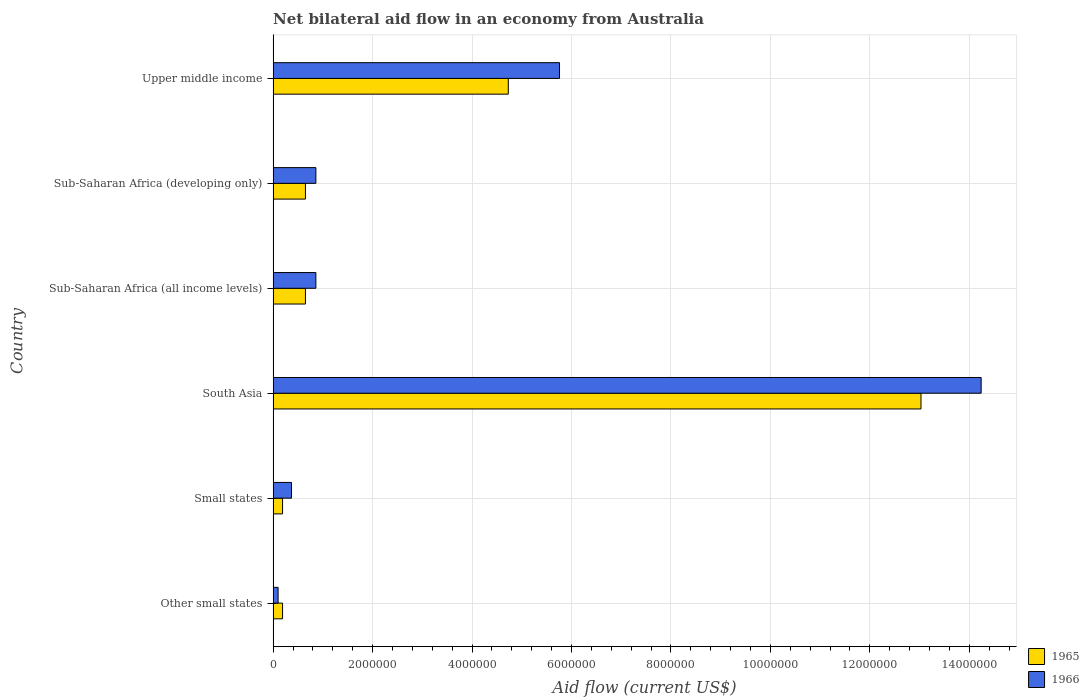How many different coloured bars are there?
Give a very brief answer. 2. Are the number of bars per tick equal to the number of legend labels?
Give a very brief answer. Yes. Are the number of bars on each tick of the Y-axis equal?
Your answer should be compact. Yes. How many bars are there on the 3rd tick from the top?
Make the answer very short. 2. How many bars are there on the 2nd tick from the bottom?
Your answer should be compact. 2. What is the label of the 5th group of bars from the top?
Keep it short and to the point. Small states. What is the net bilateral aid flow in 1965 in Sub-Saharan Africa (developing only)?
Keep it short and to the point. 6.50e+05. Across all countries, what is the maximum net bilateral aid flow in 1965?
Offer a terse response. 1.30e+07. Across all countries, what is the minimum net bilateral aid flow in 1965?
Keep it short and to the point. 1.90e+05. In which country was the net bilateral aid flow in 1965 maximum?
Your answer should be compact. South Asia. In which country was the net bilateral aid flow in 1966 minimum?
Your answer should be compact. Other small states. What is the total net bilateral aid flow in 1965 in the graph?
Offer a very short reply. 1.94e+07. What is the difference between the net bilateral aid flow in 1966 in Other small states and that in Sub-Saharan Africa (all income levels)?
Offer a terse response. -7.60e+05. What is the difference between the net bilateral aid flow in 1966 in Upper middle income and the net bilateral aid flow in 1965 in Other small states?
Your response must be concise. 5.57e+06. What is the average net bilateral aid flow in 1965 per country?
Ensure brevity in your answer.  3.24e+06. What is the difference between the net bilateral aid flow in 1965 and net bilateral aid flow in 1966 in Upper middle income?
Your response must be concise. -1.03e+06. In how many countries, is the net bilateral aid flow in 1966 greater than 6400000 US$?
Your answer should be very brief. 1. What is the ratio of the net bilateral aid flow in 1966 in Other small states to that in Sub-Saharan Africa (developing only)?
Your response must be concise. 0.12. Is the net bilateral aid flow in 1965 in Small states less than that in Sub-Saharan Africa (developing only)?
Ensure brevity in your answer.  Yes. Is the difference between the net bilateral aid flow in 1965 in South Asia and Sub-Saharan Africa (all income levels) greater than the difference between the net bilateral aid flow in 1966 in South Asia and Sub-Saharan Africa (all income levels)?
Give a very brief answer. No. What is the difference between the highest and the second highest net bilateral aid flow in 1965?
Keep it short and to the point. 8.30e+06. What is the difference between the highest and the lowest net bilateral aid flow in 1966?
Give a very brief answer. 1.41e+07. Is the sum of the net bilateral aid flow in 1966 in Sub-Saharan Africa (developing only) and Upper middle income greater than the maximum net bilateral aid flow in 1965 across all countries?
Make the answer very short. No. What does the 1st bar from the top in Other small states represents?
Offer a terse response. 1966. What does the 2nd bar from the bottom in Sub-Saharan Africa (all income levels) represents?
Make the answer very short. 1966. Are all the bars in the graph horizontal?
Offer a terse response. Yes. Are the values on the major ticks of X-axis written in scientific E-notation?
Make the answer very short. No. Does the graph contain any zero values?
Keep it short and to the point. No. Does the graph contain grids?
Offer a very short reply. Yes. Where does the legend appear in the graph?
Keep it short and to the point. Bottom right. How many legend labels are there?
Ensure brevity in your answer.  2. What is the title of the graph?
Your response must be concise. Net bilateral aid flow in an economy from Australia. What is the Aid flow (current US$) of 1965 in Other small states?
Give a very brief answer. 1.90e+05. What is the Aid flow (current US$) of 1965 in South Asia?
Your answer should be very brief. 1.30e+07. What is the Aid flow (current US$) of 1966 in South Asia?
Give a very brief answer. 1.42e+07. What is the Aid flow (current US$) of 1965 in Sub-Saharan Africa (all income levels)?
Offer a very short reply. 6.50e+05. What is the Aid flow (current US$) in 1966 in Sub-Saharan Africa (all income levels)?
Offer a very short reply. 8.60e+05. What is the Aid flow (current US$) in 1965 in Sub-Saharan Africa (developing only)?
Your answer should be compact. 6.50e+05. What is the Aid flow (current US$) of 1966 in Sub-Saharan Africa (developing only)?
Ensure brevity in your answer.  8.60e+05. What is the Aid flow (current US$) in 1965 in Upper middle income?
Your answer should be very brief. 4.73e+06. What is the Aid flow (current US$) of 1966 in Upper middle income?
Your response must be concise. 5.76e+06. Across all countries, what is the maximum Aid flow (current US$) of 1965?
Give a very brief answer. 1.30e+07. Across all countries, what is the maximum Aid flow (current US$) of 1966?
Your response must be concise. 1.42e+07. Across all countries, what is the minimum Aid flow (current US$) in 1965?
Your answer should be very brief. 1.90e+05. What is the total Aid flow (current US$) of 1965 in the graph?
Your answer should be very brief. 1.94e+07. What is the total Aid flow (current US$) of 1966 in the graph?
Provide a short and direct response. 2.22e+07. What is the difference between the Aid flow (current US$) in 1966 in Other small states and that in Small states?
Keep it short and to the point. -2.70e+05. What is the difference between the Aid flow (current US$) in 1965 in Other small states and that in South Asia?
Your answer should be compact. -1.28e+07. What is the difference between the Aid flow (current US$) of 1966 in Other small states and that in South Asia?
Your response must be concise. -1.41e+07. What is the difference between the Aid flow (current US$) in 1965 in Other small states and that in Sub-Saharan Africa (all income levels)?
Your answer should be compact. -4.60e+05. What is the difference between the Aid flow (current US$) of 1966 in Other small states and that in Sub-Saharan Africa (all income levels)?
Make the answer very short. -7.60e+05. What is the difference between the Aid flow (current US$) in 1965 in Other small states and that in Sub-Saharan Africa (developing only)?
Provide a succinct answer. -4.60e+05. What is the difference between the Aid flow (current US$) in 1966 in Other small states and that in Sub-Saharan Africa (developing only)?
Provide a succinct answer. -7.60e+05. What is the difference between the Aid flow (current US$) in 1965 in Other small states and that in Upper middle income?
Ensure brevity in your answer.  -4.54e+06. What is the difference between the Aid flow (current US$) of 1966 in Other small states and that in Upper middle income?
Offer a very short reply. -5.66e+06. What is the difference between the Aid flow (current US$) in 1965 in Small states and that in South Asia?
Provide a short and direct response. -1.28e+07. What is the difference between the Aid flow (current US$) in 1966 in Small states and that in South Asia?
Provide a succinct answer. -1.39e+07. What is the difference between the Aid flow (current US$) in 1965 in Small states and that in Sub-Saharan Africa (all income levels)?
Offer a very short reply. -4.60e+05. What is the difference between the Aid flow (current US$) of 1966 in Small states and that in Sub-Saharan Africa (all income levels)?
Make the answer very short. -4.90e+05. What is the difference between the Aid flow (current US$) in 1965 in Small states and that in Sub-Saharan Africa (developing only)?
Make the answer very short. -4.60e+05. What is the difference between the Aid flow (current US$) in 1966 in Small states and that in Sub-Saharan Africa (developing only)?
Provide a short and direct response. -4.90e+05. What is the difference between the Aid flow (current US$) in 1965 in Small states and that in Upper middle income?
Offer a very short reply. -4.54e+06. What is the difference between the Aid flow (current US$) of 1966 in Small states and that in Upper middle income?
Give a very brief answer. -5.39e+06. What is the difference between the Aid flow (current US$) in 1965 in South Asia and that in Sub-Saharan Africa (all income levels)?
Offer a terse response. 1.24e+07. What is the difference between the Aid flow (current US$) in 1966 in South Asia and that in Sub-Saharan Africa (all income levels)?
Your answer should be compact. 1.34e+07. What is the difference between the Aid flow (current US$) of 1965 in South Asia and that in Sub-Saharan Africa (developing only)?
Make the answer very short. 1.24e+07. What is the difference between the Aid flow (current US$) in 1966 in South Asia and that in Sub-Saharan Africa (developing only)?
Offer a very short reply. 1.34e+07. What is the difference between the Aid flow (current US$) in 1965 in South Asia and that in Upper middle income?
Keep it short and to the point. 8.30e+06. What is the difference between the Aid flow (current US$) in 1966 in South Asia and that in Upper middle income?
Keep it short and to the point. 8.48e+06. What is the difference between the Aid flow (current US$) in 1965 in Sub-Saharan Africa (all income levels) and that in Sub-Saharan Africa (developing only)?
Provide a succinct answer. 0. What is the difference between the Aid flow (current US$) of 1966 in Sub-Saharan Africa (all income levels) and that in Sub-Saharan Africa (developing only)?
Ensure brevity in your answer.  0. What is the difference between the Aid flow (current US$) of 1965 in Sub-Saharan Africa (all income levels) and that in Upper middle income?
Offer a very short reply. -4.08e+06. What is the difference between the Aid flow (current US$) in 1966 in Sub-Saharan Africa (all income levels) and that in Upper middle income?
Offer a very short reply. -4.90e+06. What is the difference between the Aid flow (current US$) in 1965 in Sub-Saharan Africa (developing only) and that in Upper middle income?
Make the answer very short. -4.08e+06. What is the difference between the Aid flow (current US$) in 1966 in Sub-Saharan Africa (developing only) and that in Upper middle income?
Offer a terse response. -4.90e+06. What is the difference between the Aid flow (current US$) in 1965 in Other small states and the Aid flow (current US$) in 1966 in South Asia?
Your answer should be compact. -1.40e+07. What is the difference between the Aid flow (current US$) in 1965 in Other small states and the Aid flow (current US$) in 1966 in Sub-Saharan Africa (all income levels)?
Provide a short and direct response. -6.70e+05. What is the difference between the Aid flow (current US$) in 1965 in Other small states and the Aid flow (current US$) in 1966 in Sub-Saharan Africa (developing only)?
Offer a very short reply. -6.70e+05. What is the difference between the Aid flow (current US$) in 1965 in Other small states and the Aid flow (current US$) in 1966 in Upper middle income?
Your answer should be compact. -5.57e+06. What is the difference between the Aid flow (current US$) of 1965 in Small states and the Aid flow (current US$) of 1966 in South Asia?
Your response must be concise. -1.40e+07. What is the difference between the Aid flow (current US$) in 1965 in Small states and the Aid flow (current US$) in 1966 in Sub-Saharan Africa (all income levels)?
Provide a short and direct response. -6.70e+05. What is the difference between the Aid flow (current US$) in 1965 in Small states and the Aid flow (current US$) in 1966 in Sub-Saharan Africa (developing only)?
Make the answer very short. -6.70e+05. What is the difference between the Aid flow (current US$) in 1965 in Small states and the Aid flow (current US$) in 1966 in Upper middle income?
Ensure brevity in your answer.  -5.57e+06. What is the difference between the Aid flow (current US$) of 1965 in South Asia and the Aid flow (current US$) of 1966 in Sub-Saharan Africa (all income levels)?
Give a very brief answer. 1.22e+07. What is the difference between the Aid flow (current US$) of 1965 in South Asia and the Aid flow (current US$) of 1966 in Sub-Saharan Africa (developing only)?
Offer a terse response. 1.22e+07. What is the difference between the Aid flow (current US$) in 1965 in South Asia and the Aid flow (current US$) in 1966 in Upper middle income?
Give a very brief answer. 7.27e+06. What is the difference between the Aid flow (current US$) in 1965 in Sub-Saharan Africa (all income levels) and the Aid flow (current US$) in 1966 in Upper middle income?
Give a very brief answer. -5.11e+06. What is the difference between the Aid flow (current US$) of 1965 in Sub-Saharan Africa (developing only) and the Aid flow (current US$) of 1966 in Upper middle income?
Make the answer very short. -5.11e+06. What is the average Aid flow (current US$) of 1965 per country?
Provide a succinct answer. 3.24e+06. What is the average Aid flow (current US$) of 1966 per country?
Ensure brevity in your answer.  3.70e+06. What is the difference between the Aid flow (current US$) in 1965 and Aid flow (current US$) in 1966 in South Asia?
Offer a terse response. -1.21e+06. What is the difference between the Aid flow (current US$) of 1965 and Aid flow (current US$) of 1966 in Sub-Saharan Africa (all income levels)?
Offer a terse response. -2.10e+05. What is the difference between the Aid flow (current US$) in 1965 and Aid flow (current US$) in 1966 in Upper middle income?
Your response must be concise. -1.03e+06. What is the ratio of the Aid flow (current US$) in 1965 in Other small states to that in Small states?
Provide a succinct answer. 1. What is the ratio of the Aid flow (current US$) in 1966 in Other small states to that in Small states?
Your answer should be very brief. 0.27. What is the ratio of the Aid flow (current US$) of 1965 in Other small states to that in South Asia?
Offer a very short reply. 0.01. What is the ratio of the Aid flow (current US$) of 1966 in Other small states to that in South Asia?
Your response must be concise. 0.01. What is the ratio of the Aid flow (current US$) of 1965 in Other small states to that in Sub-Saharan Africa (all income levels)?
Offer a terse response. 0.29. What is the ratio of the Aid flow (current US$) in 1966 in Other small states to that in Sub-Saharan Africa (all income levels)?
Your answer should be compact. 0.12. What is the ratio of the Aid flow (current US$) in 1965 in Other small states to that in Sub-Saharan Africa (developing only)?
Your response must be concise. 0.29. What is the ratio of the Aid flow (current US$) of 1966 in Other small states to that in Sub-Saharan Africa (developing only)?
Provide a short and direct response. 0.12. What is the ratio of the Aid flow (current US$) in 1965 in Other small states to that in Upper middle income?
Offer a terse response. 0.04. What is the ratio of the Aid flow (current US$) in 1966 in Other small states to that in Upper middle income?
Ensure brevity in your answer.  0.02. What is the ratio of the Aid flow (current US$) of 1965 in Small states to that in South Asia?
Provide a succinct answer. 0.01. What is the ratio of the Aid flow (current US$) of 1966 in Small states to that in South Asia?
Your answer should be very brief. 0.03. What is the ratio of the Aid flow (current US$) of 1965 in Small states to that in Sub-Saharan Africa (all income levels)?
Provide a short and direct response. 0.29. What is the ratio of the Aid flow (current US$) in 1966 in Small states to that in Sub-Saharan Africa (all income levels)?
Provide a short and direct response. 0.43. What is the ratio of the Aid flow (current US$) in 1965 in Small states to that in Sub-Saharan Africa (developing only)?
Offer a terse response. 0.29. What is the ratio of the Aid flow (current US$) of 1966 in Small states to that in Sub-Saharan Africa (developing only)?
Provide a short and direct response. 0.43. What is the ratio of the Aid flow (current US$) in 1965 in Small states to that in Upper middle income?
Your answer should be compact. 0.04. What is the ratio of the Aid flow (current US$) of 1966 in Small states to that in Upper middle income?
Give a very brief answer. 0.06. What is the ratio of the Aid flow (current US$) of 1965 in South Asia to that in Sub-Saharan Africa (all income levels)?
Your answer should be compact. 20.05. What is the ratio of the Aid flow (current US$) of 1966 in South Asia to that in Sub-Saharan Africa (all income levels)?
Offer a very short reply. 16.56. What is the ratio of the Aid flow (current US$) of 1965 in South Asia to that in Sub-Saharan Africa (developing only)?
Provide a short and direct response. 20.05. What is the ratio of the Aid flow (current US$) in 1966 in South Asia to that in Sub-Saharan Africa (developing only)?
Offer a terse response. 16.56. What is the ratio of the Aid flow (current US$) of 1965 in South Asia to that in Upper middle income?
Provide a short and direct response. 2.75. What is the ratio of the Aid flow (current US$) in 1966 in South Asia to that in Upper middle income?
Your answer should be very brief. 2.47. What is the ratio of the Aid flow (current US$) of 1965 in Sub-Saharan Africa (all income levels) to that in Upper middle income?
Your answer should be very brief. 0.14. What is the ratio of the Aid flow (current US$) of 1966 in Sub-Saharan Africa (all income levels) to that in Upper middle income?
Provide a short and direct response. 0.15. What is the ratio of the Aid flow (current US$) of 1965 in Sub-Saharan Africa (developing only) to that in Upper middle income?
Offer a very short reply. 0.14. What is the ratio of the Aid flow (current US$) of 1966 in Sub-Saharan Africa (developing only) to that in Upper middle income?
Make the answer very short. 0.15. What is the difference between the highest and the second highest Aid flow (current US$) in 1965?
Provide a succinct answer. 8.30e+06. What is the difference between the highest and the second highest Aid flow (current US$) in 1966?
Your answer should be compact. 8.48e+06. What is the difference between the highest and the lowest Aid flow (current US$) of 1965?
Make the answer very short. 1.28e+07. What is the difference between the highest and the lowest Aid flow (current US$) in 1966?
Your answer should be compact. 1.41e+07. 